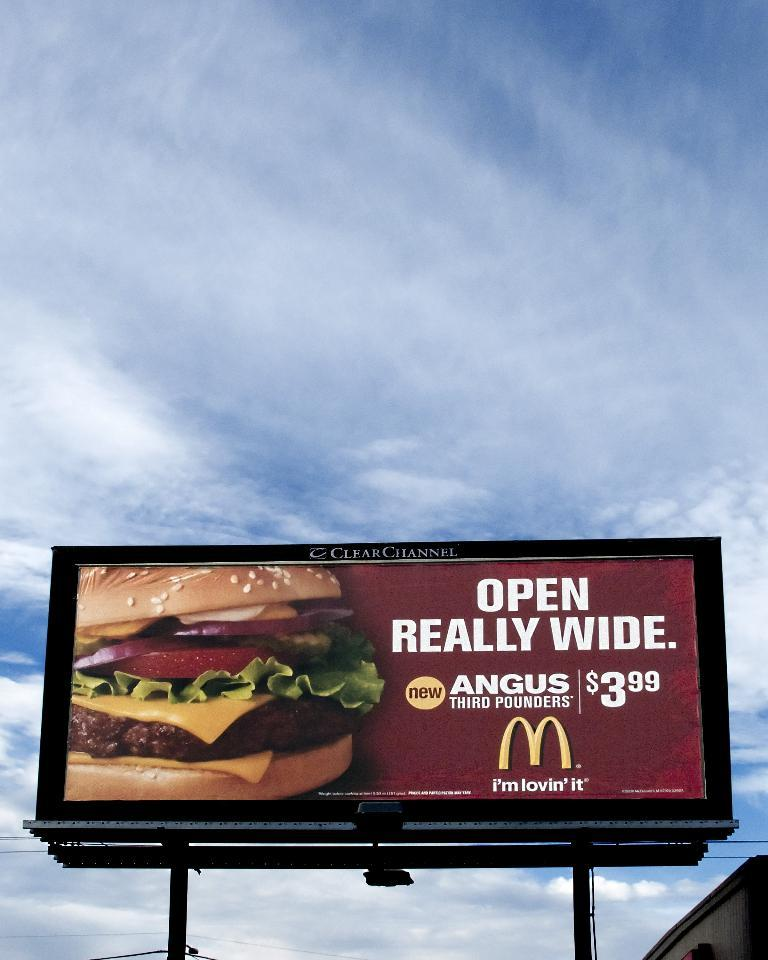Provide a one-sentence caption for the provided image. Open Really Wide, advises the billboard for the McDonald's Angus third pounders for only $3.99. 